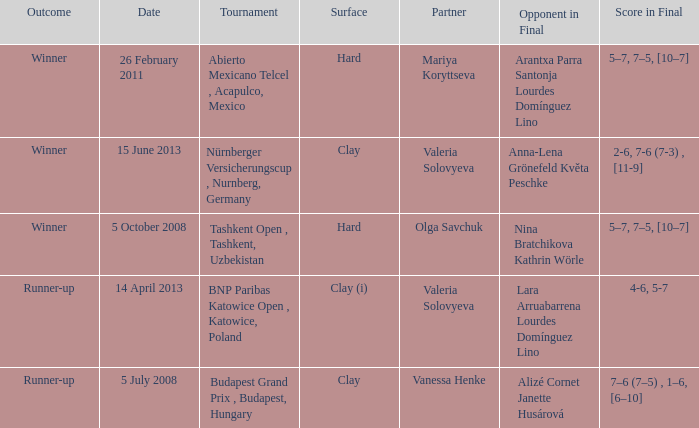Which partner was on 14 april 2013? Valeria Solovyeva. 